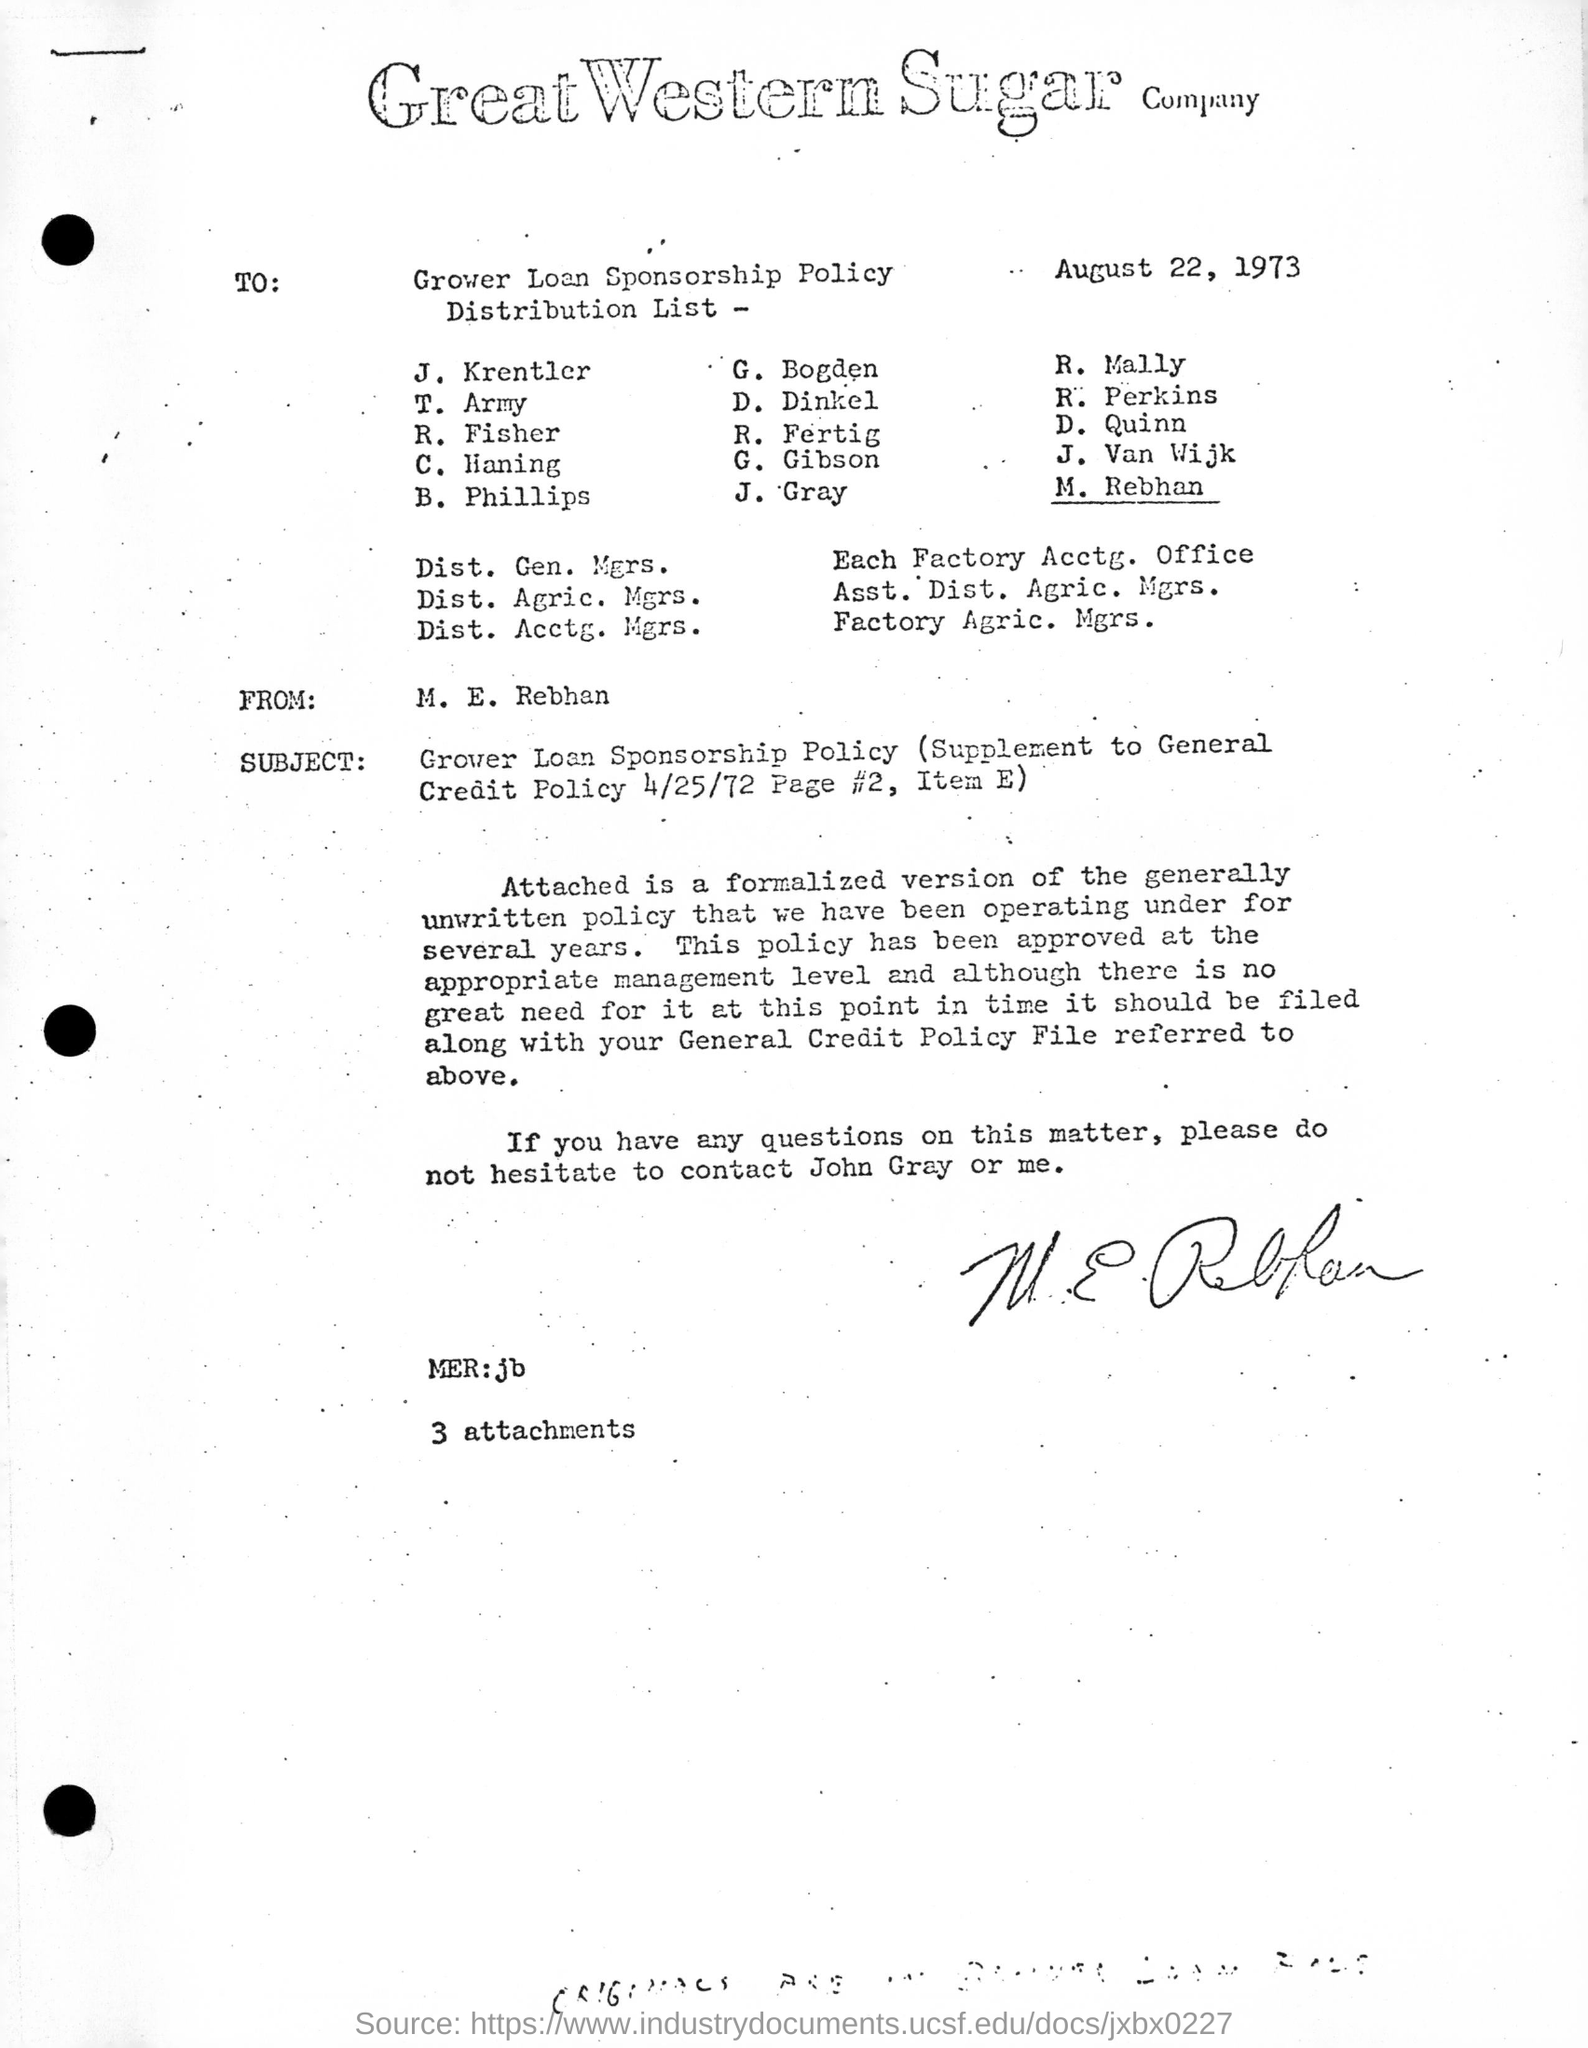Which company's name is on the letterhead?
Give a very brief answer. Great Western Sugar company. Who is this letter addressed to ?
Your response must be concise. GROWER LOAN SPONSORSHIP POLICY. What is the date on the letter
Provide a succinct answer. AUGUST 22, 1973. Who wrote this letter?
Give a very brief answer. M. E. Rebhan. 